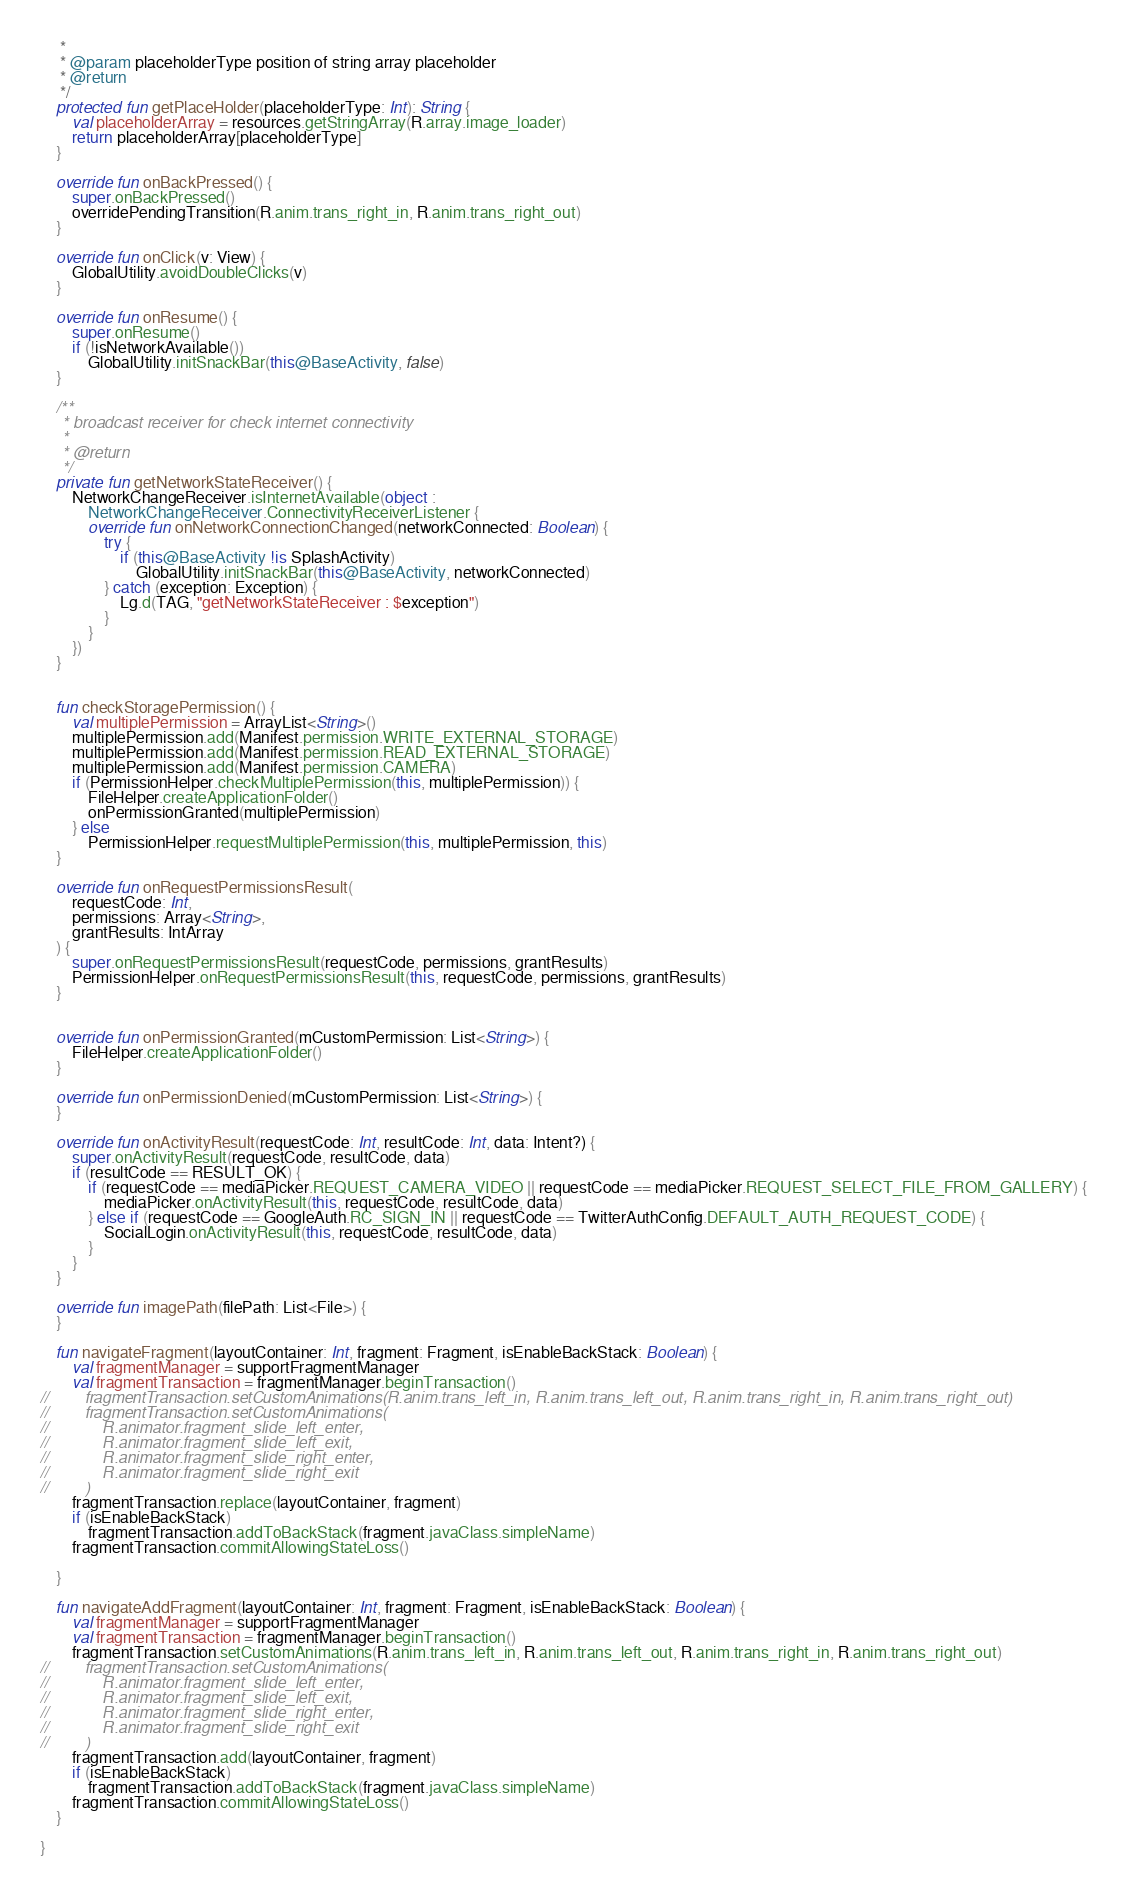<code> <loc_0><loc_0><loc_500><loc_500><_Kotlin_>     *
     * @param placeholderType position of string array placeholder
     * @return
     */
    protected fun getPlaceHolder(placeholderType: Int): String {
        val placeholderArray = resources.getStringArray(R.array.image_loader)
        return placeholderArray[placeholderType]
    }

    override fun onBackPressed() {
        super.onBackPressed()
        overridePendingTransition(R.anim.trans_right_in, R.anim.trans_right_out)
    }

    override fun onClick(v: View) {
        GlobalUtility.avoidDoubleClicks(v)
    }

    override fun onResume() {
        super.onResume()
        if (!isNetworkAvailable())
            GlobalUtility.initSnackBar(this@BaseActivity, false)
    }

    /**
     * broadcast receiver for check internet connectivity
     *
     * @return
     */
    private fun getNetworkStateReceiver() {
        NetworkChangeReceiver.isInternetAvailable(object :
            NetworkChangeReceiver.ConnectivityReceiverListener {
            override fun onNetworkConnectionChanged(networkConnected: Boolean) {
                try {
                    if (this@BaseActivity !is SplashActivity)
                        GlobalUtility.initSnackBar(this@BaseActivity, networkConnected)
                } catch (exception: Exception) {
                    Lg.d(TAG, "getNetworkStateReceiver : $exception")
                }
            }
        })
    }


    fun checkStoragePermission() {
        val multiplePermission = ArrayList<String>()
        multiplePermission.add(Manifest.permission.WRITE_EXTERNAL_STORAGE)
        multiplePermission.add(Manifest.permission.READ_EXTERNAL_STORAGE)
        multiplePermission.add(Manifest.permission.CAMERA)
        if (PermissionHelper.checkMultiplePermission(this, multiplePermission)) {
            FileHelper.createApplicationFolder()
            onPermissionGranted(multiplePermission)
        } else
            PermissionHelper.requestMultiplePermission(this, multiplePermission, this)
    }

    override fun onRequestPermissionsResult(
        requestCode: Int,
        permissions: Array<String>,
        grantResults: IntArray
    ) {
        super.onRequestPermissionsResult(requestCode, permissions, grantResults)
        PermissionHelper.onRequestPermissionsResult(this, requestCode, permissions, grantResults)
    }


    override fun onPermissionGranted(mCustomPermission: List<String>) {
        FileHelper.createApplicationFolder()
    }

    override fun onPermissionDenied(mCustomPermission: List<String>) {
    }

    override fun onActivityResult(requestCode: Int, resultCode: Int, data: Intent?) {
        super.onActivityResult(requestCode, resultCode, data)
        if (resultCode == RESULT_OK) {
            if (requestCode == mediaPicker.REQUEST_CAMERA_VIDEO || requestCode == mediaPicker.REQUEST_SELECT_FILE_FROM_GALLERY) {
                mediaPicker.onActivityResult(this, requestCode, resultCode, data)
            } else if (requestCode == GoogleAuth.RC_SIGN_IN || requestCode == TwitterAuthConfig.DEFAULT_AUTH_REQUEST_CODE) {
                SocialLogin.onActivityResult(this, requestCode, resultCode, data)
            }
        }
    }

    override fun imagePath(filePath: List<File>) {
    }

    fun navigateFragment(layoutContainer: Int, fragment: Fragment, isEnableBackStack: Boolean) {
        val fragmentManager = supportFragmentManager
        val fragmentTransaction = fragmentManager.beginTransaction()
//        fragmentTransaction.setCustomAnimations(R.anim.trans_left_in, R.anim.trans_left_out, R.anim.trans_right_in, R.anim.trans_right_out)
//        fragmentTransaction.setCustomAnimations(
//            R.animator.fragment_slide_left_enter,
//            R.animator.fragment_slide_left_exit,
//            R.animator.fragment_slide_right_enter,
//            R.animator.fragment_slide_right_exit
//        )
        fragmentTransaction.replace(layoutContainer, fragment)
        if (isEnableBackStack)
            fragmentTransaction.addToBackStack(fragment.javaClass.simpleName)
        fragmentTransaction.commitAllowingStateLoss()

    }

    fun navigateAddFragment(layoutContainer: Int, fragment: Fragment, isEnableBackStack: Boolean) {
        val fragmentManager = supportFragmentManager
        val fragmentTransaction = fragmentManager.beginTransaction()
        fragmentTransaction.setCustomAnimations(R.anim.trans_left_in, R.anim.trans_left_out, R.anim.trans_right_in, R.anim.trans_right_out)
//        fragmentTransaction.setCustomAnimations(
//            R.animator.fragment_slide_left_enter,
//            R.animator.fragment_slide_left_exit,
//            R.animator.fragment_slide_right_enter,
//            R.animator.fragment_slide_right_exit
//        )
        fragmentTransaction.add(layoutContainer, fragment)
        if (isEnableBackStack)
            fragmentTransaction.addToBackStack(fragment.javaClass.simpleName)
        fragmentTransaction.commitAllowingStateLoss()
    }

}</code> 